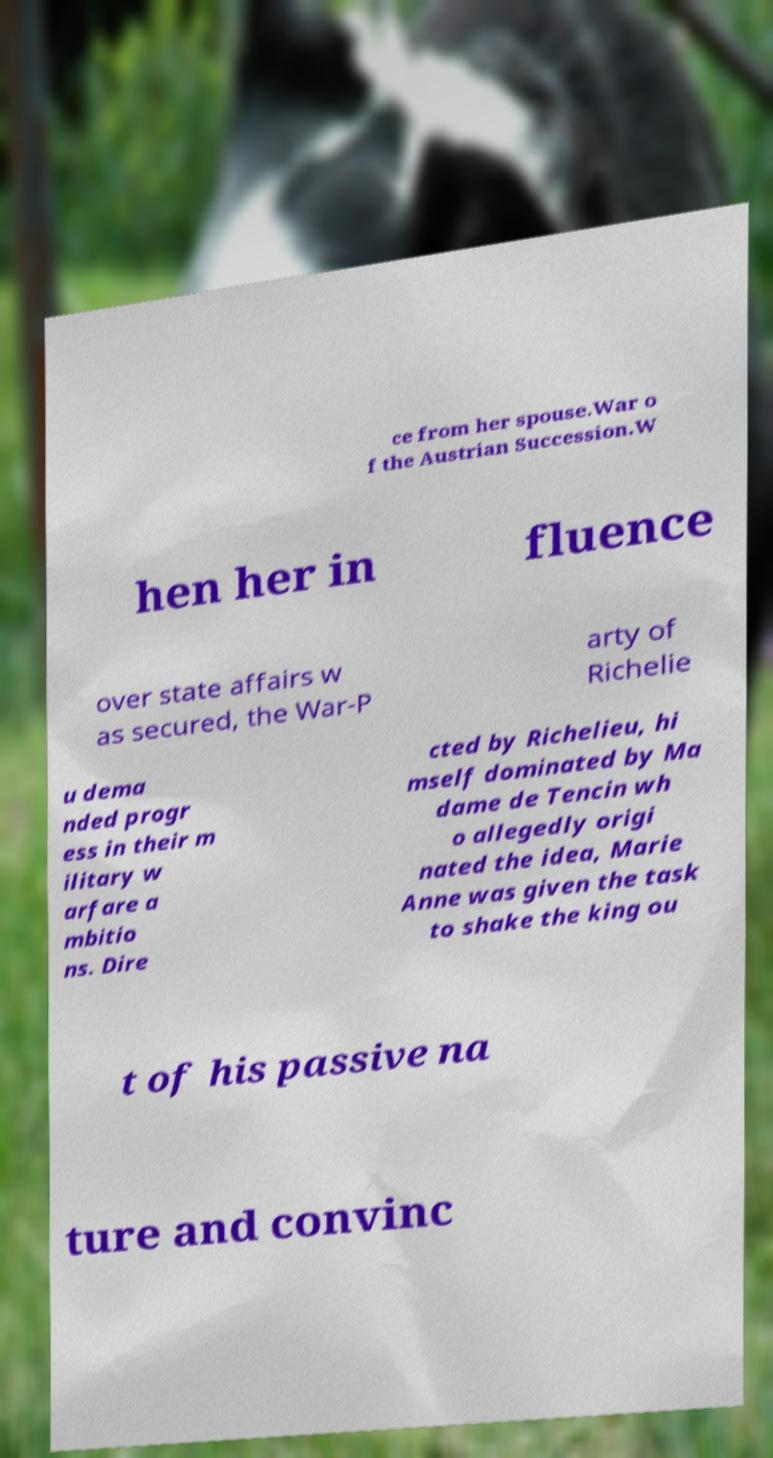There's text embedded in this image that I need extracted. Can you transcribe it verbatim? ce from her spouse.War o f the Austrian Succession.W hen her in fluence over state affairs w as secured, the War-P arty of Richelie u dema nded progr ess in their m ilitary w arfare a mbitio ns. Dire cted by Richelieu, hi mself dominated by Ma dame de Tencin wh o allegedly origi nated the idea, Marie Anne was given the task to shake the king ou t of his passive na ture and convinc 